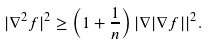<formula> <loc_0><loc_0><loc_500><loc_500>| \nabla ^ { 2 } f | ^ { 2 } \geq \left ( 1 + \frac { 1 } { n } \right ) | \nabla | \nabla f | | ^ { 2 } .</formula> 